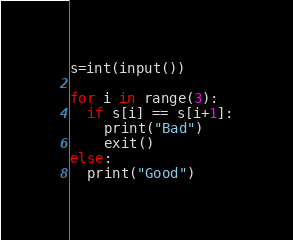Convert code to text. <code><loc_0><loc_0><loc_500><loc_500><_Python_>s=int(input())

for i in range(3):
  if s[i] == s[i+1]:
    print("Bad")
    exit()
else:
  print("Good")</code> 